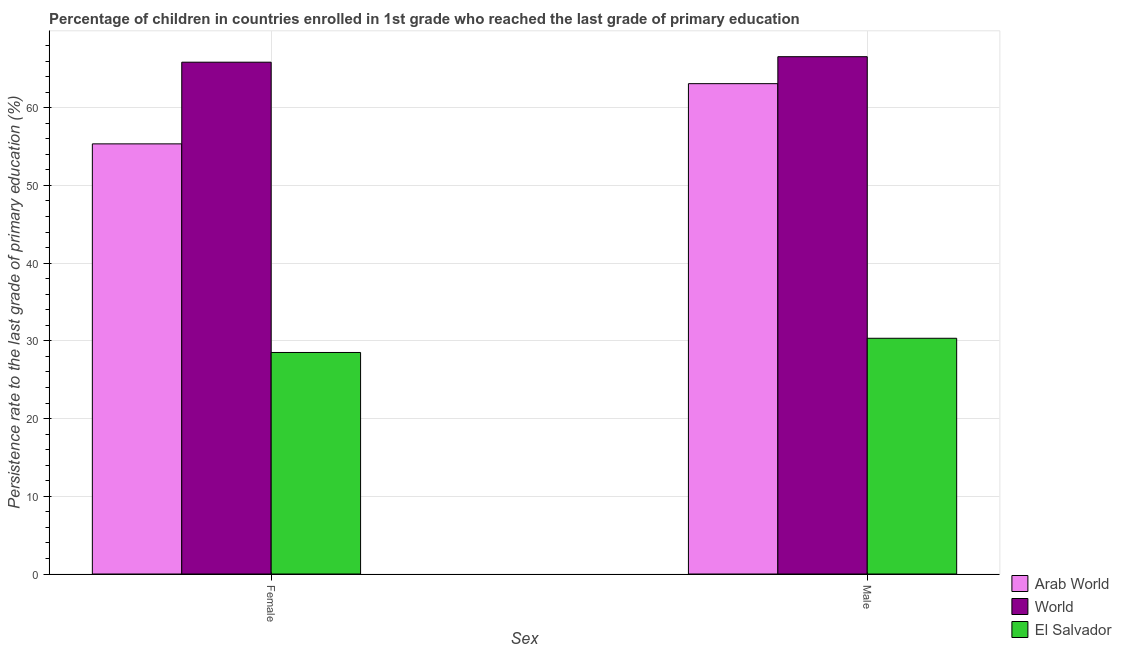How many groups of bars are there?
Offer a very short reply. 2. How many bars are there on the 1st tick from the left?
Your response must be concise. 3. How many bars are there on the 2nd tick from the right?
Offer a terse response. 3. What is the label of the 1st group of bars from the left?
Make the answer very short. Female. What is the persistence rate of male students in Arab World?
Provide a short and direct response. 63.1. Across all countries, what is the maximum persistence rate of male students?
Offer a terse response. 66.57. Across all countries, what is the minimum persistence rate of female students?
Your answer should be compact. 28.51. In which country was the persistence rate of male students maximum?
Your response must be concise. World. In which country was the persistence rate of male students minimum?
Your response must be concise. El Salvador. What is the total persistence rate of female students in the graph?
Offer a very short reply. 149.72. What is the difference between the persistence rate of male students in Arab World and that in El Salvador?
Your response must be concise. 32.76. What is the difference between the persistence rate of female students in Arab World and the persistence rate of male students in El Salvador?
Give a very brief answer. 25.02. What is the average persistence rate of male students per country?
Your answer should be compact. 53.33. What is the difference between the persistence rate of female students and persistence rate of male students in Arab World?
Give a very brief answer. -7.75. In how many countries, is the persistence rate of male students greater than 22 %?
Give a very brief answer. 3. What is the ratio of the persistence rate of female students in Arab World to that in El Salvador?
Ensure brevity in your answer.  1.94. Is the persistence rate of male students in El Salvador less than that in World?
Offer a terse response. Yes. What does the 1st bar from the left in Male represents?
Make the answer very short. Arab World. What does the 1st bar from the right in Male represents?
Your answer should be very brief. El Salvador. How many countries are there in the graph?
Provide a succinct answer. 3. Are the values on the major ticks of Y-axis written in scientific E-notation?
Make the answer very short. No. Does the graph contain grids?
Make the answer very short. Yes. How are the legend labels stacked?
Make the answer very short. Vertical. What is the title of the graph?
Your response must be concise. Percentage of children in countries enrolled in 1st grade who reached the last grade of primary education. Does "Bhutan" appear as one of the legend labels in the graph?
Ensure brevity in your answer.  No. What is the label or title of the X-axis?
Provide a short and direct response. Sex. What is the label or title of the Y-axis?
Give a very brief answer. Persistence rate to the last grade of primary education (%). What is the Persistence rate to the last grade of primary education (%) of Arab World in Female?
Provide a succinct answer. 55.35. What is the Persistence rate to the last grade of primary education (%) of World in Female?
Your answer should be compact. 65.86. What is the Persistence rate to the last grade of primary education (%) of El Salvador in Female?
Make the answer very short. 28.51. What is the Persistence rate to the last grade of primary education (%) in Arab World in Male?
Give a very brief answer. 63.1. What is the Persistence rate to the last grade of primary education (%) of World in Male?
Provide a succinct answer. 66.57. What is the Persistence rate to the last grade of primary education (%) of El Salvador in Male?
Keep it short and to the point. 30.33. Across all Sex, what is the maximum Persistence rate to the last grade of primary education (%) in Arab World?
Keep it short and to the point. 63.1. Across all Sex, what is the maximum Persistence rate to the last grade of primary education (%) of World?
Your response must be concise. 66.57. Across all Sex, what is the maximum Persistence rate to the last grade of primary education (%) in El Salvador?
Offer a terse response. 30.33. Across all Sex, what is the minimum Persistence rate to the last grade of primary education (%) in Arab World?
Provide a short and direct response. 55.35. Across all Sex, what is the minimum Persistence rate to the last grade of primary education (%) in World?
Offer a very short reply. 65.86. Across all Sex, what is the minimum Persistence rate to the last grade of primary education (%) of El Salvador?
Your answer should be very brief. 28.51. What is the total Persistence rate to the last grade of primary education (%) of Arab World in the graph?
Keep it short and to the point. 118.45. What is the total Persistence rate to the last grade of primary education (%) of World in the graph?
Keep it short and to the point. 132.43. What is the total Persistence rate to the last grade of primary education (%) of El Salvador in the graph?
Your answer should be very brief. 58.84. What is the difference between the Persistence rate to the last grade of primary education (%) of Arab World in Female and that in Male?
Keep it short and to the point. -7.75. What is the difference between the Persistence rate to the last grade of primary education (%) of World in Female and that in Male?
Your response must be concise. -0.71. What is the difference between the Persistence rate to the last grade of primary education (%) in El Salvador in Female and that in Male?
Your response must be concise. -1.83. What is the difference between the Persistence rate to the last grade of primary education (%) of Arab World in Female and the Persistence rate to the last grade of primary education (%) of World in Male?
Your response must be concise. -11.22. What is the difference between the Persistence rate to the last grade of primary education (%) of Arab World in Female and the Persistence rate to the last grade of primary education (%) of El Salvador in Male?
Provide a short and direct response. 25.02. What is the difference between the Persistence rate to the last grade of primary education (%) of World in Female and the Persistence rate to the last grade of primary education (%) of El Salvador in Male?
Provide a succinct answer. 35.53. What is the average Persistence rate to the last grade of primary education (%) of Arab World per Sex?
Your response must be concise. 59.22. What is the average Persistence rate to the last grade of primary education (%) in World per Sex?
Provide a short and direct response. 66.21. What is the average Persistence rate to the last grade of primary education (%) in El Salvador per Sex?
Provide a short and direct response. 29.42. What is the difference between the Persistence rate to the last grade of primary education (%) of Arab World and Persistence rate to the last grade of primary education (%) of World in Female?
Your response must be concise. -10.51. What is the difference between the Persistence rate to the last grade of primary education (%) of Arab World and Persistence rate to the last grade of primary education (%) of El Salvador in Female?
Offer a terse response. 26.84. What is the difference between the Persistence rate to the last grade of primary education (%) in World and Persistence rate to the last grade of primary education (%) in El Salvador in Female?
Offer a very short reply. 37.35. What is the difference between the Persistence rate to the last grade of primary education (%) of Arab World and Persistence rate to the last grade of primary education (%) of World in Male?
Offer a terse response. -3.47. What is the difference between the Persistence rate to the last grade of primary education (%) in Arab World and Persistence rate to the last grade of primary education (%) in El Salvador in Male?
Your answer should be very brief. 32.76. What is the difference between the Persistence rate to the last grade of primary education (%) of World and Persistence rate to the last grade of primary education (%) of El Salvador in Male?
Keep it short and to the point. 36.23. What is the ratio of the Persistence rate to the last grade of primary education (%) in Arab World in Female to that in Male?
Provide a succinct answer. 0.88. What is the ratio of the Persistence rate to the last grade of primary education (%) of El Salvador in Female to that in Male?
Provide a succinct answer. 0.94. What is the difference between the highest and the second highest Persistence rate to the last grade of primary education (%) of Arab World?
Ensure brevity in your answer.  7.75. What is the difference between the highest and the second highest Persistence rate to the last grade of primary education (%) of World?
Provide a short and direct response. 0.71. What is the difference between the highest and the second highest Persistence rate to the last grade of primary education (%) of El Salvador?
Provide a short and direct response. 1.83. What is the difference between the highest and the lowest Persistence rate to the last grade of primary education (%) of Arab World?
Keep it short and to the point. 7.75. What is the difference between the highest and the lowest Persistence rate to the last grade of primary education (%) in World?
Make the answer very short. 0.71. What is the difference between the highest and the lowest Persistence rate to the last grade of primary education (%) of El Salvador?
Offer a very short reply. 1.83. 